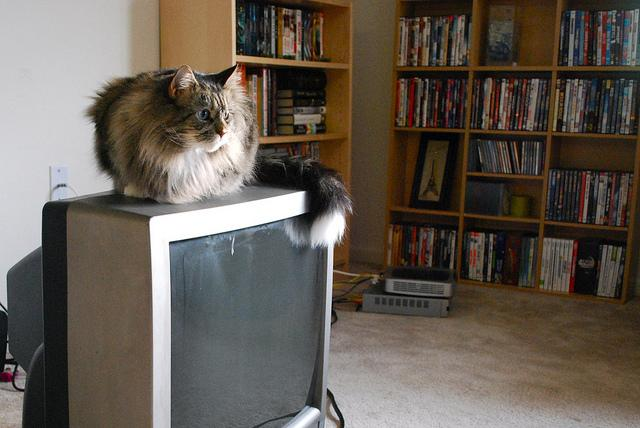What is the item that the cat is on top of used for? Please explain your reasoning. watching shows. The cat is on a tv based on the screen material and size as well as the general structure. televisions are used for watching tv and frequently for shows. 